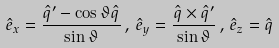Convert formula to latex. <formula><loc_0><loc_0><loc_500><loc_500>\hat { e } _ { x } = \frac { \hat { q } ^ { \prime } - \cos \vartheta \hat { q } } { \sin \vartheta } \, , \, \hat { e } _ { y } = \frac { \hat { q } \times \hat { q } ^ { \prime } } { \sin \vartheta } \, , \, \hat { e } _ { z } = \hat { q }</formula> 